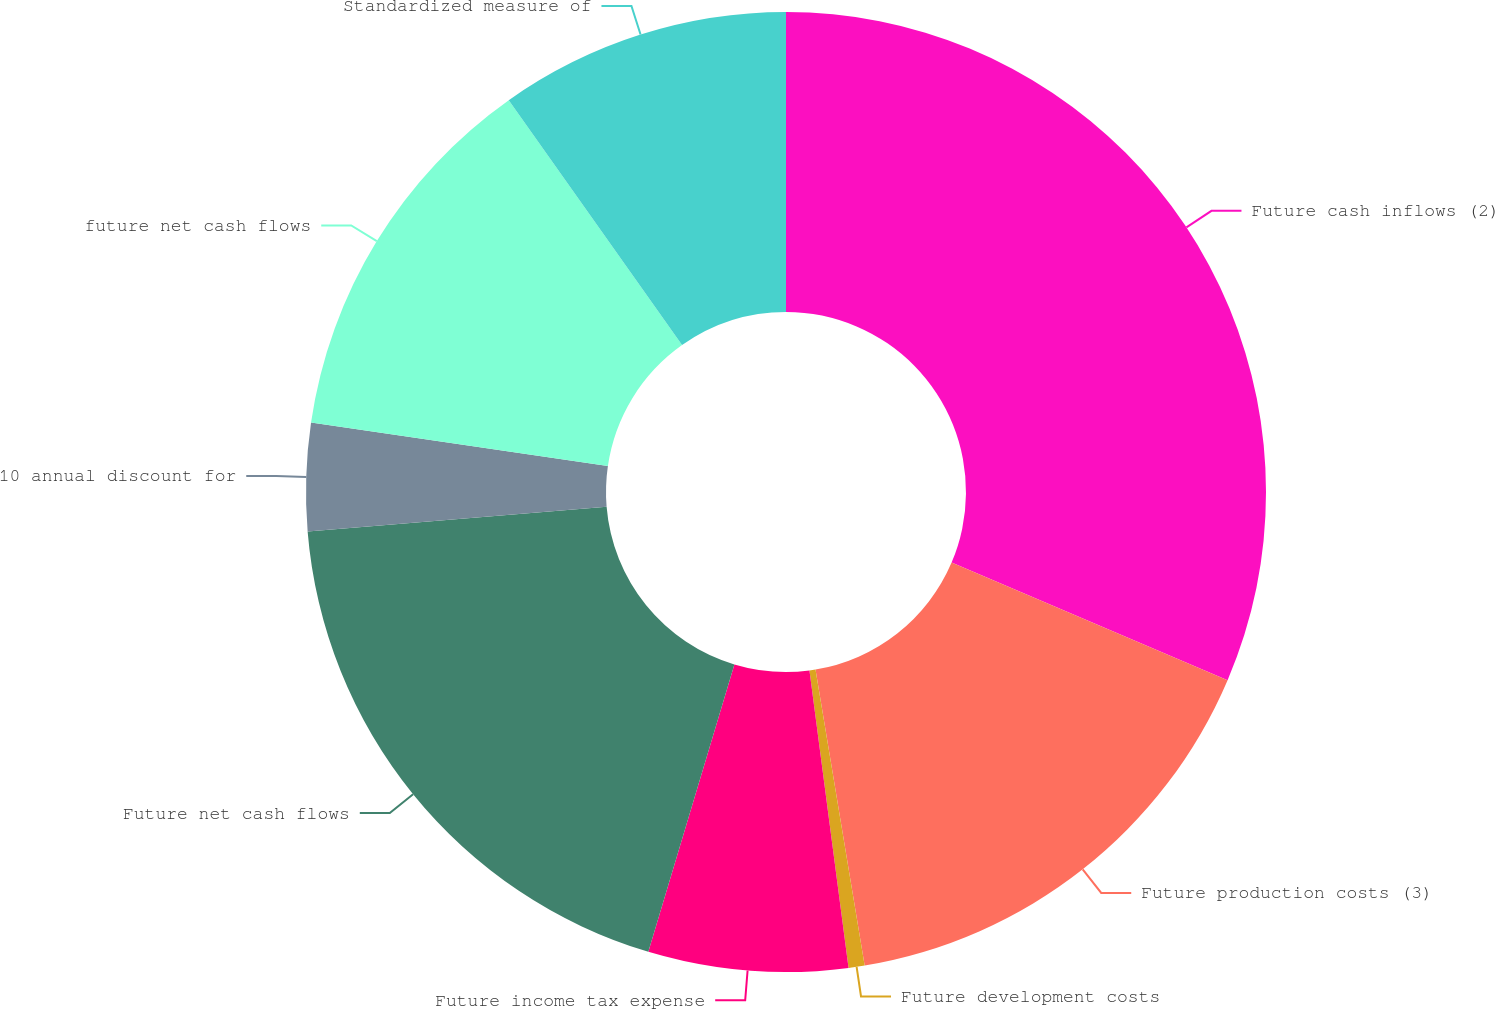Convert chart. <chart><loc_0><loc_0><loc_500><loc_500><pie_chart><fcel>Future cash inflows (2)<fcel>Future production costs (3)<fcel>Future development costs<fcel>Future income tax expense<fcel>Future net cash flows<fcel>10 annual discount for<fcel>future net cash flows<fcel>Standardized measure of<nl><fcel>31.41%<fcel>15.97%<fcel>0.54%<fcel>6.71%<fcel>19.06%<fcel>3.62%<fcel>12.89%<fcel>9.8%<nl></chart> 